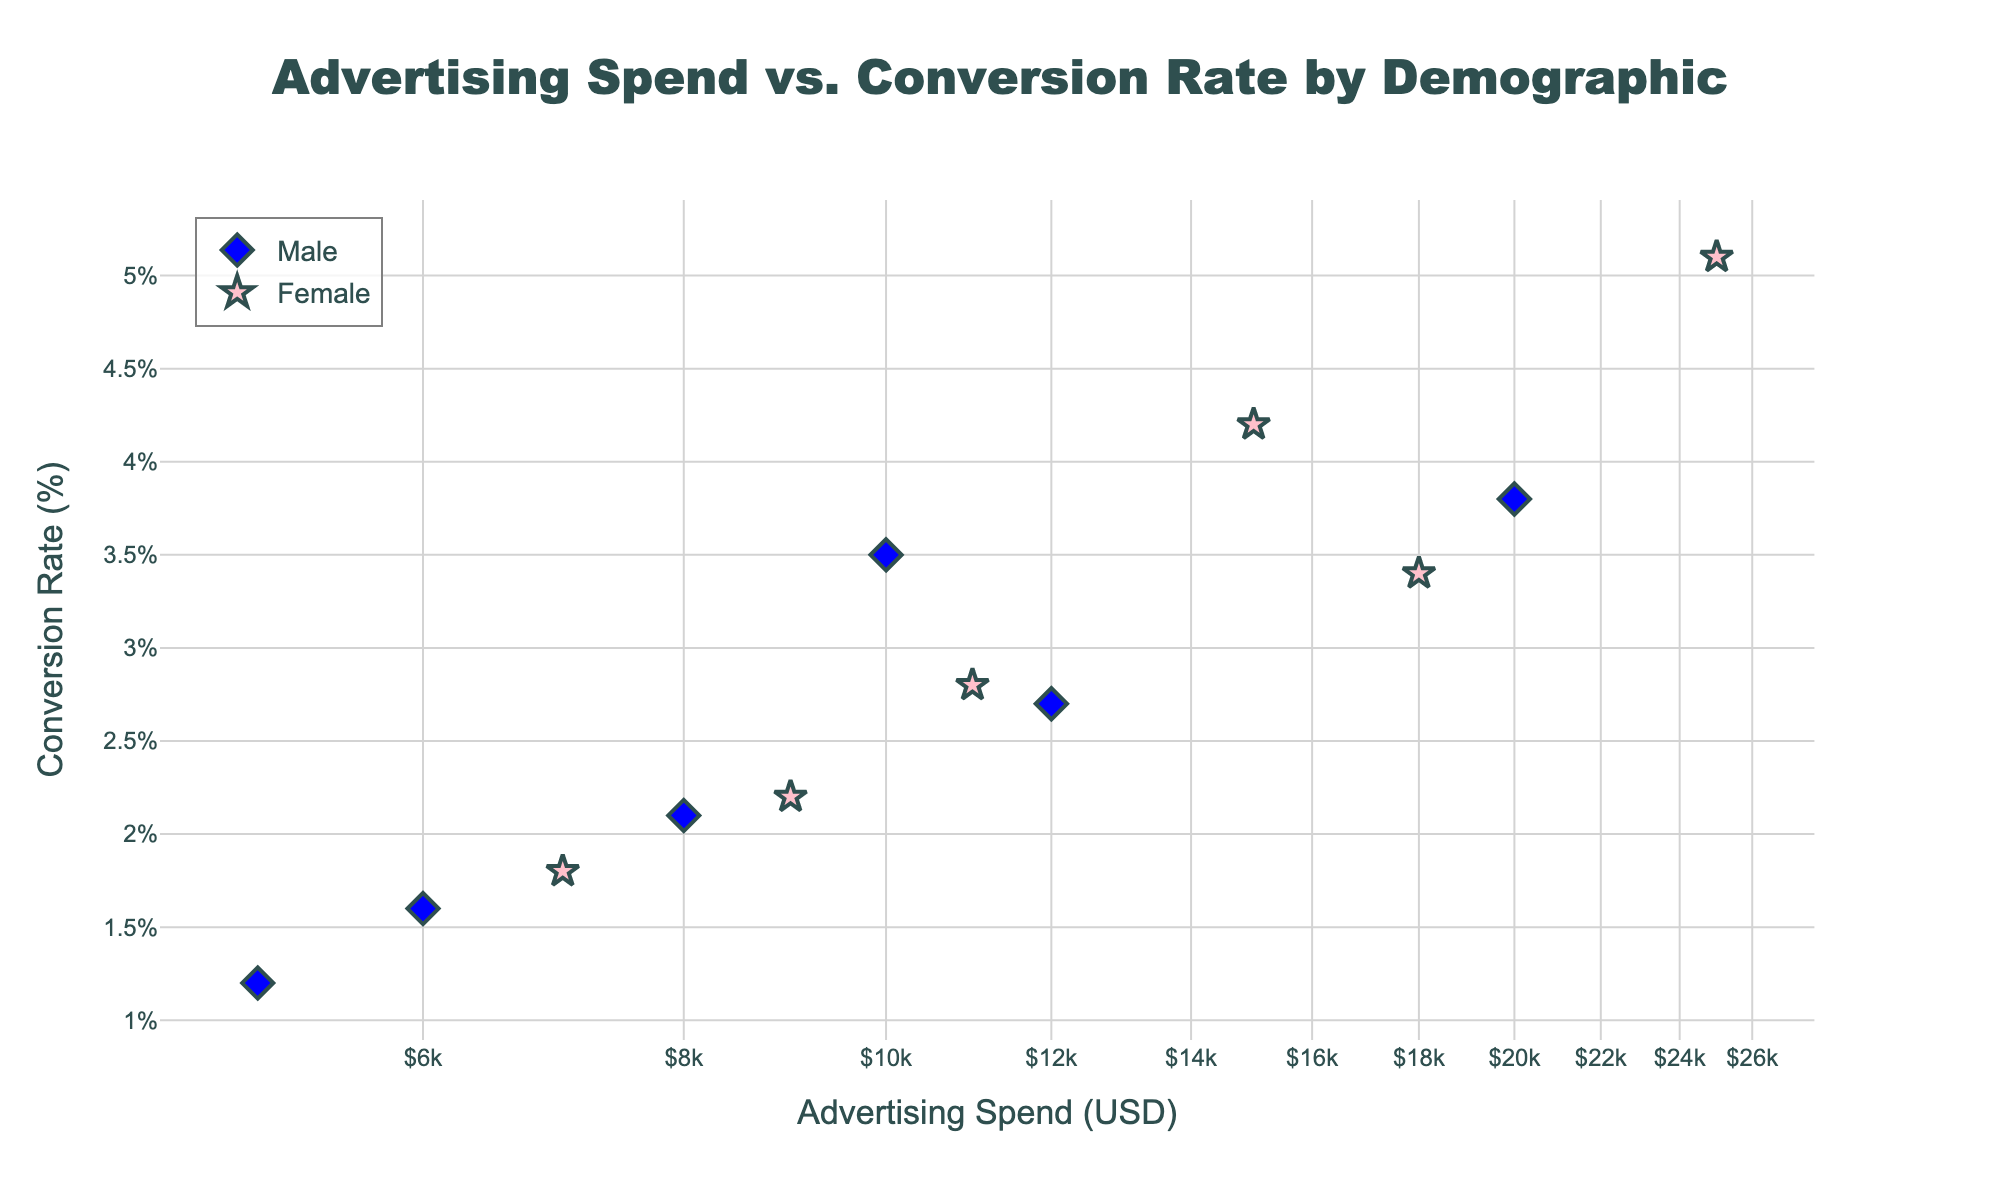what is the title of the plot? The title of the plot is shown at the top of the figure in large, bold, and dark slate grey-colored text.
Answer: "Advertising Spend vs. Conversion Rate by Demographic" How many data points are represented for female demographic segments? The figure shows markers with different colors and shapes for each demographic segment. Data points for females are represented by pink star symbols. There are six such points visible.
Answer: 6 What is the conversion rate for the "25-34 (Female)" demographic segment? By hovering over the pink star that aligns with the advertising spend of $25,000 on the x-axis, the hover text reveals the conversion rate.
Answer: 5.1% Which demographic segment has the highest conversion rate? Examining all the points, the highest conversion rate can be identified by checking the points close to the top of the y-axis. The "25-34 (Female)" point has the highest rate at 5.1%.
Answer: "25-34 (Female)" What is the difference in advertising spend between the "18-24 (Male)" and "18-24 (Female)" segments? Review the x-axis values for both segments: $15,000 for "18-24 (Female)" and $10,000 for "18-24 (Male)". Subtract the smaller from the larger.
Answer: $5,000 Which gender generally has a higher conversion rate for each age group? Compare the y-axis values of markers in blue (male) and pink (female) within each age group. Females consistently have higher rates in each group.
Answer: Females What spending level marks the lowest conversion rate for the male demographics? Find the blue diamond symbol with the lowest y-axis value. The "65+ (Male)" segment at $5,000 spend has a conversion rate of 1.2%.
Answer: $5,000 Do male or female segments achieve a higher conversion rate at an advertising spend of approximately $10,000? Both the "18-24 (Male)" and "45-54 (Female)" segments are close to $10,000 spend. By comparing their y-axis values, 45-54 (Female) at 2.8% has a higher rate than 18-24 (Male) at 3.5%.
Answer: Male How does conversion rate correlate with advertising spend on a log scale as shown in the plot? A log scale on the x-axis implies an exponential relationship. Reviewing the spread of points, higher expenditures (further right) tend to show higher conversion rates (higher y-axis), indicating a positive correlation.
Answer: Positive correlation Which demographic has the lowest conversion rate for advertising spends above $10,000? For spends above $10,000, the lowest conversion rate can be identified by looking at the bottom-most markers above the $10,000 mark. "35-44 (Male)" at a spend of $12,000 has the lowest rate of 2.7%.
Answer: "35-44 (Male)" 